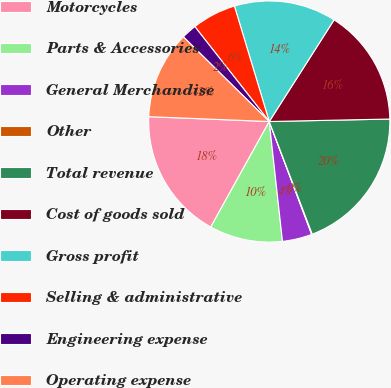<chart> <loc_0><loc_0><loc_500><loc_500><pie_chart><fcel>Motorcycles<fcel>Parts & Accessories<fcel>General Merchandise<fcel>Other<fcel>Total revenue<fcel>Cost of goods sold<fcel>Gross profit<fcel>Selling & administrative<fcel>Engineering expense<fcel>Operating expense<nl><fcel>17.58%<fcel>9.81%<fcel>3.97%<fcel>0.08%<fcel>19.53%<fcel>15.64%<fcel>13.7%<fcel>5.92%<fcel>2.03%<fcel>11.75%<nl></chart> 